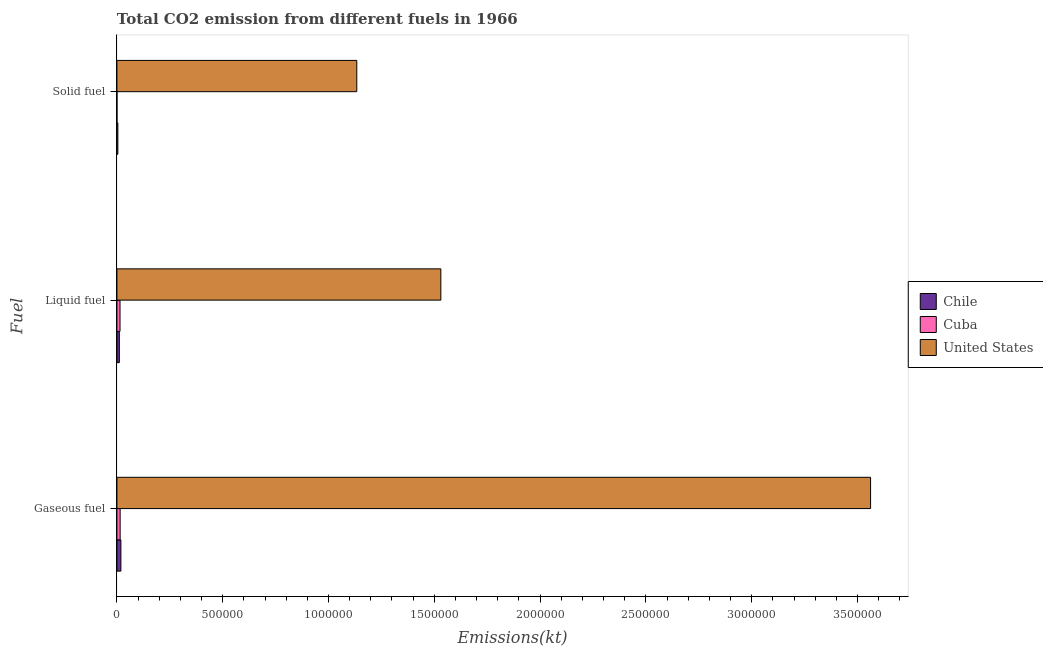How many groups of bars are there?
Provide a succinct answer. 3. Are the number of bars on each tick of the Y-axis equal?
Make the answer very short. Yes. How many bars are there on the 2nd tick from the bottom?
Your response must be concise. 3. What is the label of the 1st group of bars from the top?
Ensure brevity in your answer.  Solid fuel. What is the amount of co2 emissions from liquid fuel in Cuba?
Your response must be concise. 1.46e+04. Across all countries, what is the maximum amount of co2 emissions from gaseous fuel?
Give a very brief answer. 3.56e+06. Across all countries, what is the minimum amount of co2 emissions from solid fuel?
Your response must be concise. 168.68. In which country was the amount of co2 emissions from solid fuel maximum?
Offer a terse response. United States. In which country was the amount of co2 emissions from liquid fuel minimum?
Provide a short and direct response. Chile. What is the total amount of co2 emissions from gaseous fuel in the graph?
Provide a short and direct response. 3.60e+06. What is the difference between the amount of co2 emissions from gaseous fuel in Chile and that in United States?
Keep it short and to the point. -3.54e+06. What is the difference between the amount of co2 emissions from gaseous fuel in United States and the amount of co2 emissions from solid fuel in Cuba?
Offer a terse response. 3.56e+06. What is the average amount of co2 emissions from gaseous fuel per country?
Your answer should be compact. 1.20e+06. What is the difference between the amount of co2 emissions from solid fuel and amount of co2 emissions from gaseous fuel in Cuba?
Provide a short and direct response. -1.50e+04. In how many countries, is the amount of co2 emissions from gaseous fuel greater than 1400000 kt?
Provide a succinct answer. 1. What is the ratio of the amount of co2 emissions from liquid fuel in Chile to that in Cuba?
Offer a terse response. 0.78. Is the difference between the amount of co2 emissions from gaseous fuel in Cuba and United States greater than the difference between the amount of co2 emissions from liquid fuel in Cuba and United States?
Provide a succinct answer. No. What is the difference between the highest and the second highest amount of co2 emissions from solid fuel?
Offer a very short reply. 1.13e+06. What is the difference between the highest and the lowest amount of co2 emissions from liquid fuel?
Keep it short and to the point. 1.52e+06. In how many countries, is the amount of co2 emissions from liquid fuel greater than the average amount of co2 emissions from liquid fuel taken over all countries?
Offer a terse response. 1. Is the sum of the amount of co2 emissions from solid fuel in Chile and United States greater than the maximum amount of co2 emissions from gaseous fuel across all countries?
Your answer should be compact. No. What does the 3rd bar from the top in Liquid fuel represents?
Provide a short and direct response. Chile. What does the 1st bar from the bottom in Liquid fuel represents?
Your answer should be very brief. Chile. Is it the case that in every country, the sum of the amount of co2 emissions from gaseous fuel and amount of co2 emissions from liquid fuel is greater than the amount of co2 emissions from solid fuel?
Provide a short and direct response. Yes. How many bars are there?
Provide a short and direct response. 9. Are all the bars in the graph horizontal?
Offer a terse response. Yes. What is the difference between two consecutive major ticks on the X-axis?
Provide a succinct answer. 5.00e+05. Does the graph contain any zero values?
Provide a succinct answer. No. Does the graph contain grids?
Provide a succinct answer. No. How many legend labels are there?
Your answer should be very brief. 3. How are the legend labels stacked?
Offer a terse response. Vertical. What is the title of the graph?
Offer a very short reply. Total CO2 emission from different fuels in 1966. What is the label or title of the X-axis?
Give a very brief answer. Emissions(kt). What is the label or title of the Y-axis?
Make the answer very short. Fuel. What is the Emissions(kt) of Chile in Gaseous fuel?
Your answer should be very brief. 1.88e+04. What is the Emissions(kt) in Cuba in Gaseous fuel?
Ensure brevity in your answer.  1.52e+04. What is the Emissions(kt) of United States in Gaseous fuel?
Offer a terse response. 3.56e+06. What is the Emissions(kt) in Chile in Liquid fuel?
Provide a succinct answer. 1.14e+04. What is the Emissions(kt) of Cuba in Liquid fuel?
Ensure brevity in your answer.  1.46e+04. What is the Emissions(kt) of United States in Liquid fuel?
Your response must be concise. 1.53e+06. What is the Emissions(kt) of Chile in Solid fuel?
Your answer should be compact. 4338.06. What is the Emissions(kt) in Cuba in Solid fuel?
Make the answer very short. 168.68. What is the Emissions(kt) in United States in Solid fuel?
Provide a short and direct response. 1.13e+06. Across all Fuel, what is the maximum Emissions(kt) in Chile?
Provide a succinct answer. 1.88e+04. Across all Fuel, what is the maximum Emissions(kt) of Cuba?
Offer a very short reply. 1.52e+04. Across all Fuel, what is the maximum Emissions(kt) of United States?
Ensure brevity in your answer.  3.56e+06. Across all Fuel, what is the minimum Emissions(kt) in Chile?
Ensure brevity in your answer.  4338.06. Across all Fuel, what is the minimum Emissions(kt) of Cuba?
Keep it short and to the point. 168.68. Across all Fuel, what is the minimum Emissions(kt) of United States?
Give a very brief answer. 1.13e+06. What is the total Emissions(kt) of Chile in the graph?
Provide a short and direct response. 3.46e+04. What is the total Emissions(kt) of Cuba in the graph?
Give a very brief answer. 3.00e+04. What is the total Emissions(kt) in United States in the graph?
Your answer should be very brief. 6.23e+06. What is the difference between the Emissions(kt) of Chile in Gaseous fuel and that in Liquid fuel?
Keep it short and to the point. 7352.34. What is the difference between the Emissions(kt) of Cuba in Gaseous fuel and that in Liquid fuel?
Ensure brevity in your answer.  568.38. What is the difference between the Emissions(kt) of United States in Gaseous fuel and that in Liquid fuel?
Make the answer very short. 2.03e+06. What is the difference between the Emissions(kt) in Chile in Gaseous fuel and that in Solid fuel?
Offer a terse response. 1.45e+04. What is the difference between the Emissions(kt) of Cuba in Gaseous fuel and that in Solid fuel?
Your answer should be very brief. 1.50e+04. What is the difference between the Emissions(kt) in United States in Gaseous fuel and that in Solid fuel?
Provide a succinct answer. 2.43e+06. What is the difference between the Emissions(kt) in Chile in Liquid fuel and that in Solid fuel?
Your response must be concise. 7102.98. What is the difference between the Emissions(kt) of Cuba in Liquid fuel and that in Solid fuel?
Offer a terse response. 1.44e+04. What is the difference between the Emissions(kt) in United States in Liquid fuel and that in Solid fuel?
Ensure brevity in your answer.  3.97e+05. What is the difference between the Emissions(kt) in Chile in Gaseous fuel and the Emissions(kt) in Cuba in Liquid fuel?
Your answer should be compact. 4176.71. What is the difference between the Emissions(kt) in Chile in Gaseous fuel and the Emissions(kt) in United States in Liquid fuel?
Your answer should be compact. -1.51e+06. What is the difference between the Emissions(kt) of Cuba in Gaseous fuel and the Emissions(kt) of United States in Liquid fuel?
Ensure brevity in your answer.  -1.52e+06. What is the difference between the Emissions(kt) of Chile in Gaseous fuel and the Emissions(kt) of Cuba in Solid fuel?
Your answer should be compact. 1.86e+04. What is the difference between the Emissions(kt) of Chile in Gaseous fuel and the Emissions(kt) of United States in Solid fuel?
Offer a very short reply. -1.11e+06. What is the difference between the Emissions(kt) in Cuba in Gaseous fuel and the Emissions(kt) in United States in Solid fuel?
Ensure brevity in your answer.  -1.12e+06. What is the difference between the Emissions(kt) of Chile in Liquid fuel and the Emissions(kt) of Cuba in Solid fuel?
Make the answer very short. 1.13e+04. What is the difference between the Emissions(kt) in Chile in Liquid fuel and the Emissions(kt) in United States in Solid fuel?
Provide a short and direct response. -1.12e+06. What is the difference between the Emissions(kt) in Cuba in Liquid fuel and the Emissions(kt) in United States in Solid fuel?
Ensure brevity in your answer.  -1.12e+06. What is the average Emissions(kt) in Chile per Fuel?
Your answer should be very brief. 1.15e+04. What is the average Emissions(kt) in Cuba per Fuel?
Keep it short and to the point. 9990.13. What is the average Emissions(kt) in United States per Fuel?
Give a very brief answer. 2.08e+06. What is the difference between the Emissions(kt) in Chile and Emissions(kt) in Cuba in Gaseous fuel?
Offer a terse response. 3608.33. What is the difference between the Emissions(kt) of Chile and Emissions(kt) of United States in Gaseous fuel?
Make the answer very short. -3.54e+06. What is the difference between the Emissions(kt) in Cuba and Emissions(kt) in United States in Gaseous fuel?
Your response must be concise. -3.55e+06. What is the difference between the Emissions(kt) of Chile and Emissions(kt) of Cuba in Liquid fuel?
Provide a short and direct response. -3175.62. What is the difference between the Emissions(kt) in Chile and Emissions(kt) in United States in Liquid fuel?
Your answer should be compact. -1.52e+06. What is the difference between the Emissions(kt) in Cuba and Emissions(kt) in United States in Liquid fuel?
Ensure brevity in your answer.  -1.52e+06. What is the difference between the Emissions(kt) in Chile and Emissions(kt) in Cuba in Solid fuel?
Provide a succinct answer. 4169.38. What is the difference between the Emissions(kt) in Chile and Emissions(kt) in United States in Solid fuel?
Provide a succinct answer. -1.13e+06. What is the difference between the Emissions(kt) of Cuba and Emissions(kt) of United States in Solid fuel?
Keep it short and to the point. -1.13e+06. What is the ratio of the Emissions(kt) of Chile in Gaseous fuel to that in Liquid fuel?
Give a very brief answer. 1.64. What is the ratio of the Emissions(kt) of Cuba in Gaseous fuel to that in Liquid fuel?
Provide a short and direct response. 1.04. What is the ratio of the Emissions(kt) in United States in Gaseous fuel to that in Liquid fuel?
Your response must be concise. 2.33. What is the ratio of the Emissions(kt) of Chile in Gaseous fuel to that in Solid fuel?
Your answer should be very brief. 4.33. What is the ratio of the Emissions(kt) in Cuba in Gaseous fuel to that in Solid fuel?
Your answer should be compact. 90.02. What is the ratio of the Emissions(kt) in United States in Gaseous fuel to that in Solid fuel?
Keep it short and to the point. 3.14. What is the ratio of the Emissions(kt) in Chile in Liquid fuel to that in Solid fuel?
Your answer should be very brief. 2.64. What is the ratio of the Emissions(kt) in Cuba in Liquid fuel to that in Solid fuel?
Ensure brevity in your answer.  86.65. What is the ratio of the Emissions(kt) in United States in Liquid fuel to that in Solid fuel?
Ensure brevity in your answer.  1.35. What is the difference between the highest and the second highest Emissions(kt) in Chile?
Ensure brevity in your answer.  7352.34. What is the difference between the highest and the second highest Emissions(kt) of Cuba?
Give a very brief answer. 568.38. What is the difference between the highest and the second highest Emissions(kt) in United States?
Ensure brevity in your answer.  2.03e+06. What is the difference between the highest and the lowest Emissions(kt) in Chile?
Make the answer very short. 1.45e+04. What is the difference between the highest and the lowest Emissions(kt) of Cuba?
Keep it short and to the point. 1.50e+04. What is the difference between the highest and the lowest Emissions(kt) of United States?
Ensure brevity in your answer.  2.43e+06. 